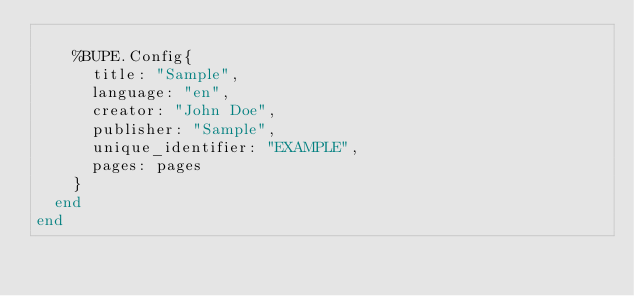Convert code to text. <code><loc_0><loc_0><loc_500><loc_500><_Elixir_>
    %BUPE.Config{
      title: "Sample",
      language: "en",
      creator: "John Doe",
      publisher: "Sample",
      unique_identifier: "EXAMPLE",
      pages: pages
    }
  end
end
</code> 